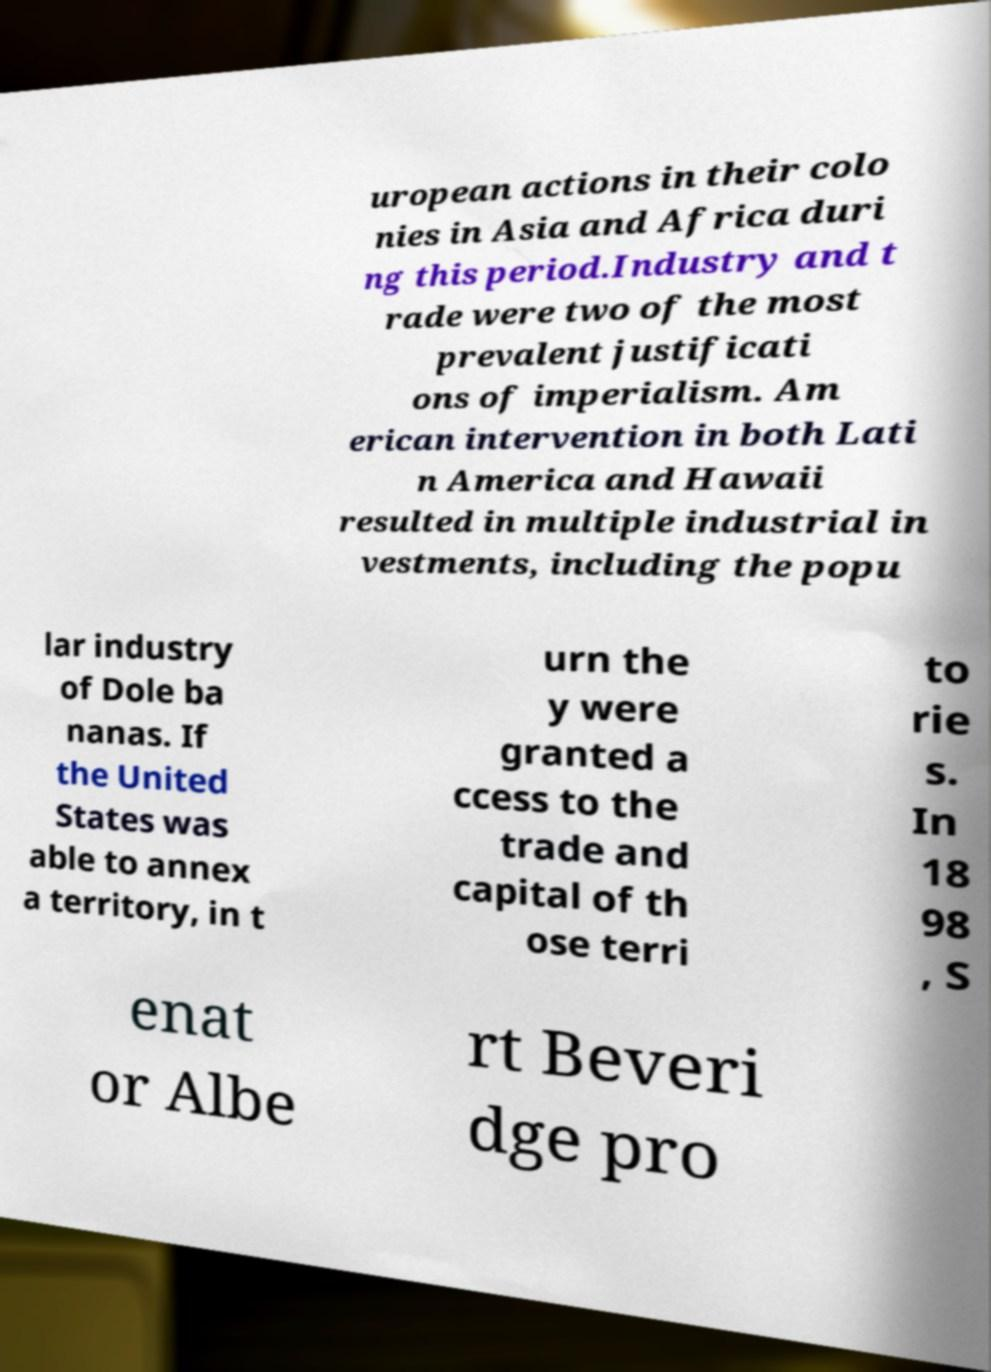Could you extract and type out the text from this image? uropean actions in their colo nies in Asia and Africa duri ng this period.Industry and t rade were two of the most prevalent justificati ons of imperialism. Am erican intervention in both Lati n America and Hawaii resulted in multiple industrial in vestments, including the popu lar industry of Dole ba nanas. If the United States was able to annex a territory, in t urn the y were granted a ccess to the trade and capital of th ose terri to rie s. In 18 98 , S enat or Albe rt Beveri dge pro 